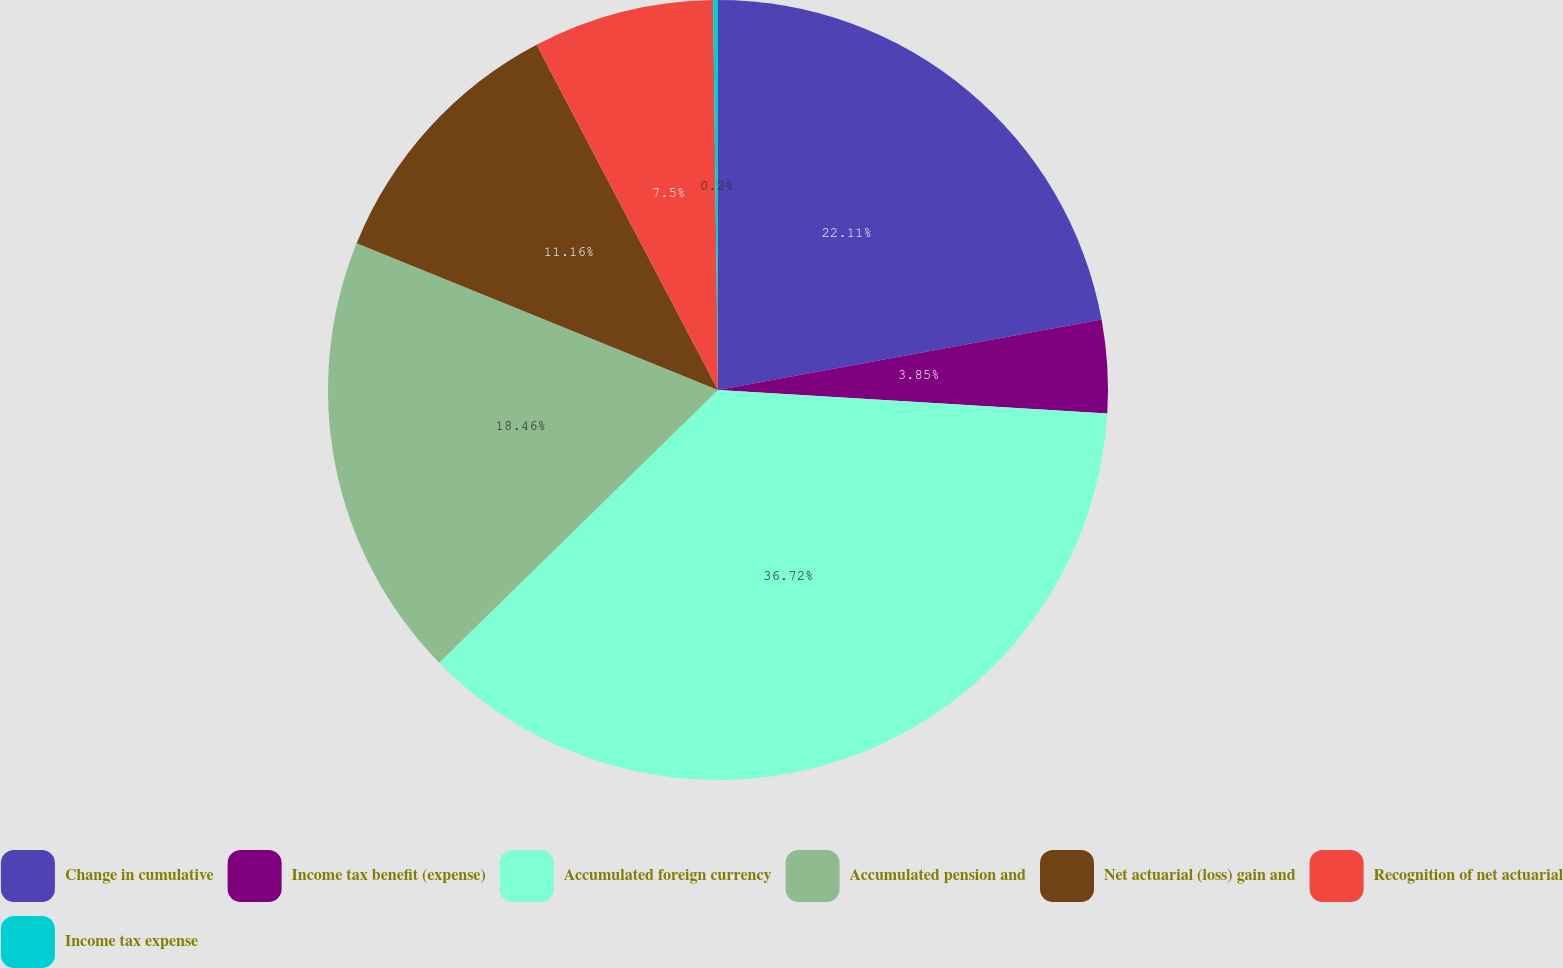<chart> <loc_0><loc_0><loc_500><loc_500><pie_chart><fcel>Change in cumulative<fcel>Income tax benefit (expense)<fcel>Accumulated foreign currency<fcel>Accumulated pension and<fcel>Net actuarial (loss) gain and<fcel>Recognition of net actuarial<fcel>Income tax expense<nl><fcel>22.11%<fcel>3.85%<fcel>36.71%<fcel>18.46%<fcel>11.16%<fcel>7.5%<fcel>0.2%<nl></chart> 